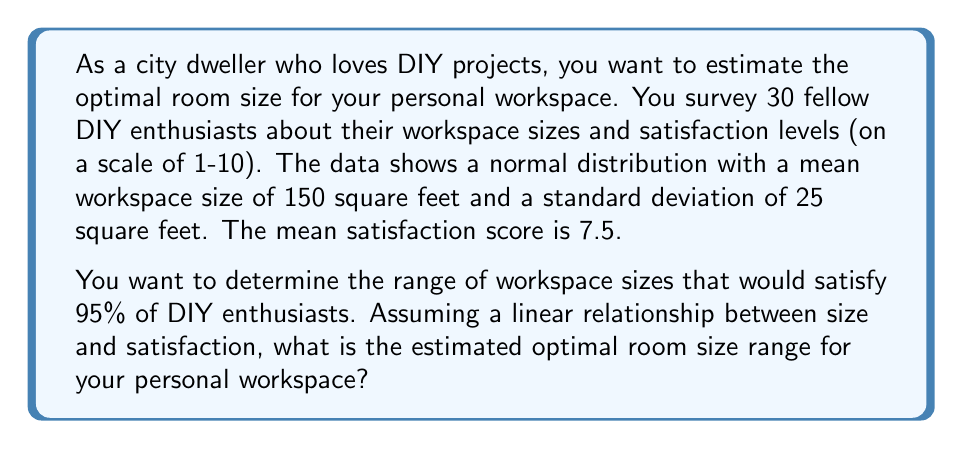Solve this math problem. To solve this problem, we'll use the properties of normal distribution and the concept of confidence intervals.

1. Given information:
   - Sample size: $n = 30$
   - Mean workspace size: $\mu = 150$ sq ft
   - Standard deviation: $\sigma = 25$ sq ft
   - Desired confidence level: 95%

2. For a 95% confidence interval, we use a z-score of 1.96 (from the standard normal distribution table).

3. The formula for confidence interval is:

   $$ CI = \mu \pm z \cdot \frac{\sigma}{\sqrt{n}} $$

4. Plugging in the values:

   $$ CI = 150 \pm 1.96 \cdot \frac{25}{\sqrt{30}} $$

5. Simplify:
   $$ CI = 150 \pm 1.96 \cdot 4.56 $$
   $$ CI = 150 \pm 8.94 $$

6. Calculate the lower and upper bounds:
   Lower bound: $150 - 8.94 = 141.06$ sq ft
   Upper bound: $150 + 8.94 = 158.94$ sq ft

7. Round to the nearest whole number for practical application:
   Optimal range: 141 sq ft to 159 sq ft
Answer: The estimated optimal room size range for your personal workspace is 141 to 159 square feet, which would satisfy 95% of DIY enthusiasts based on the given data. 